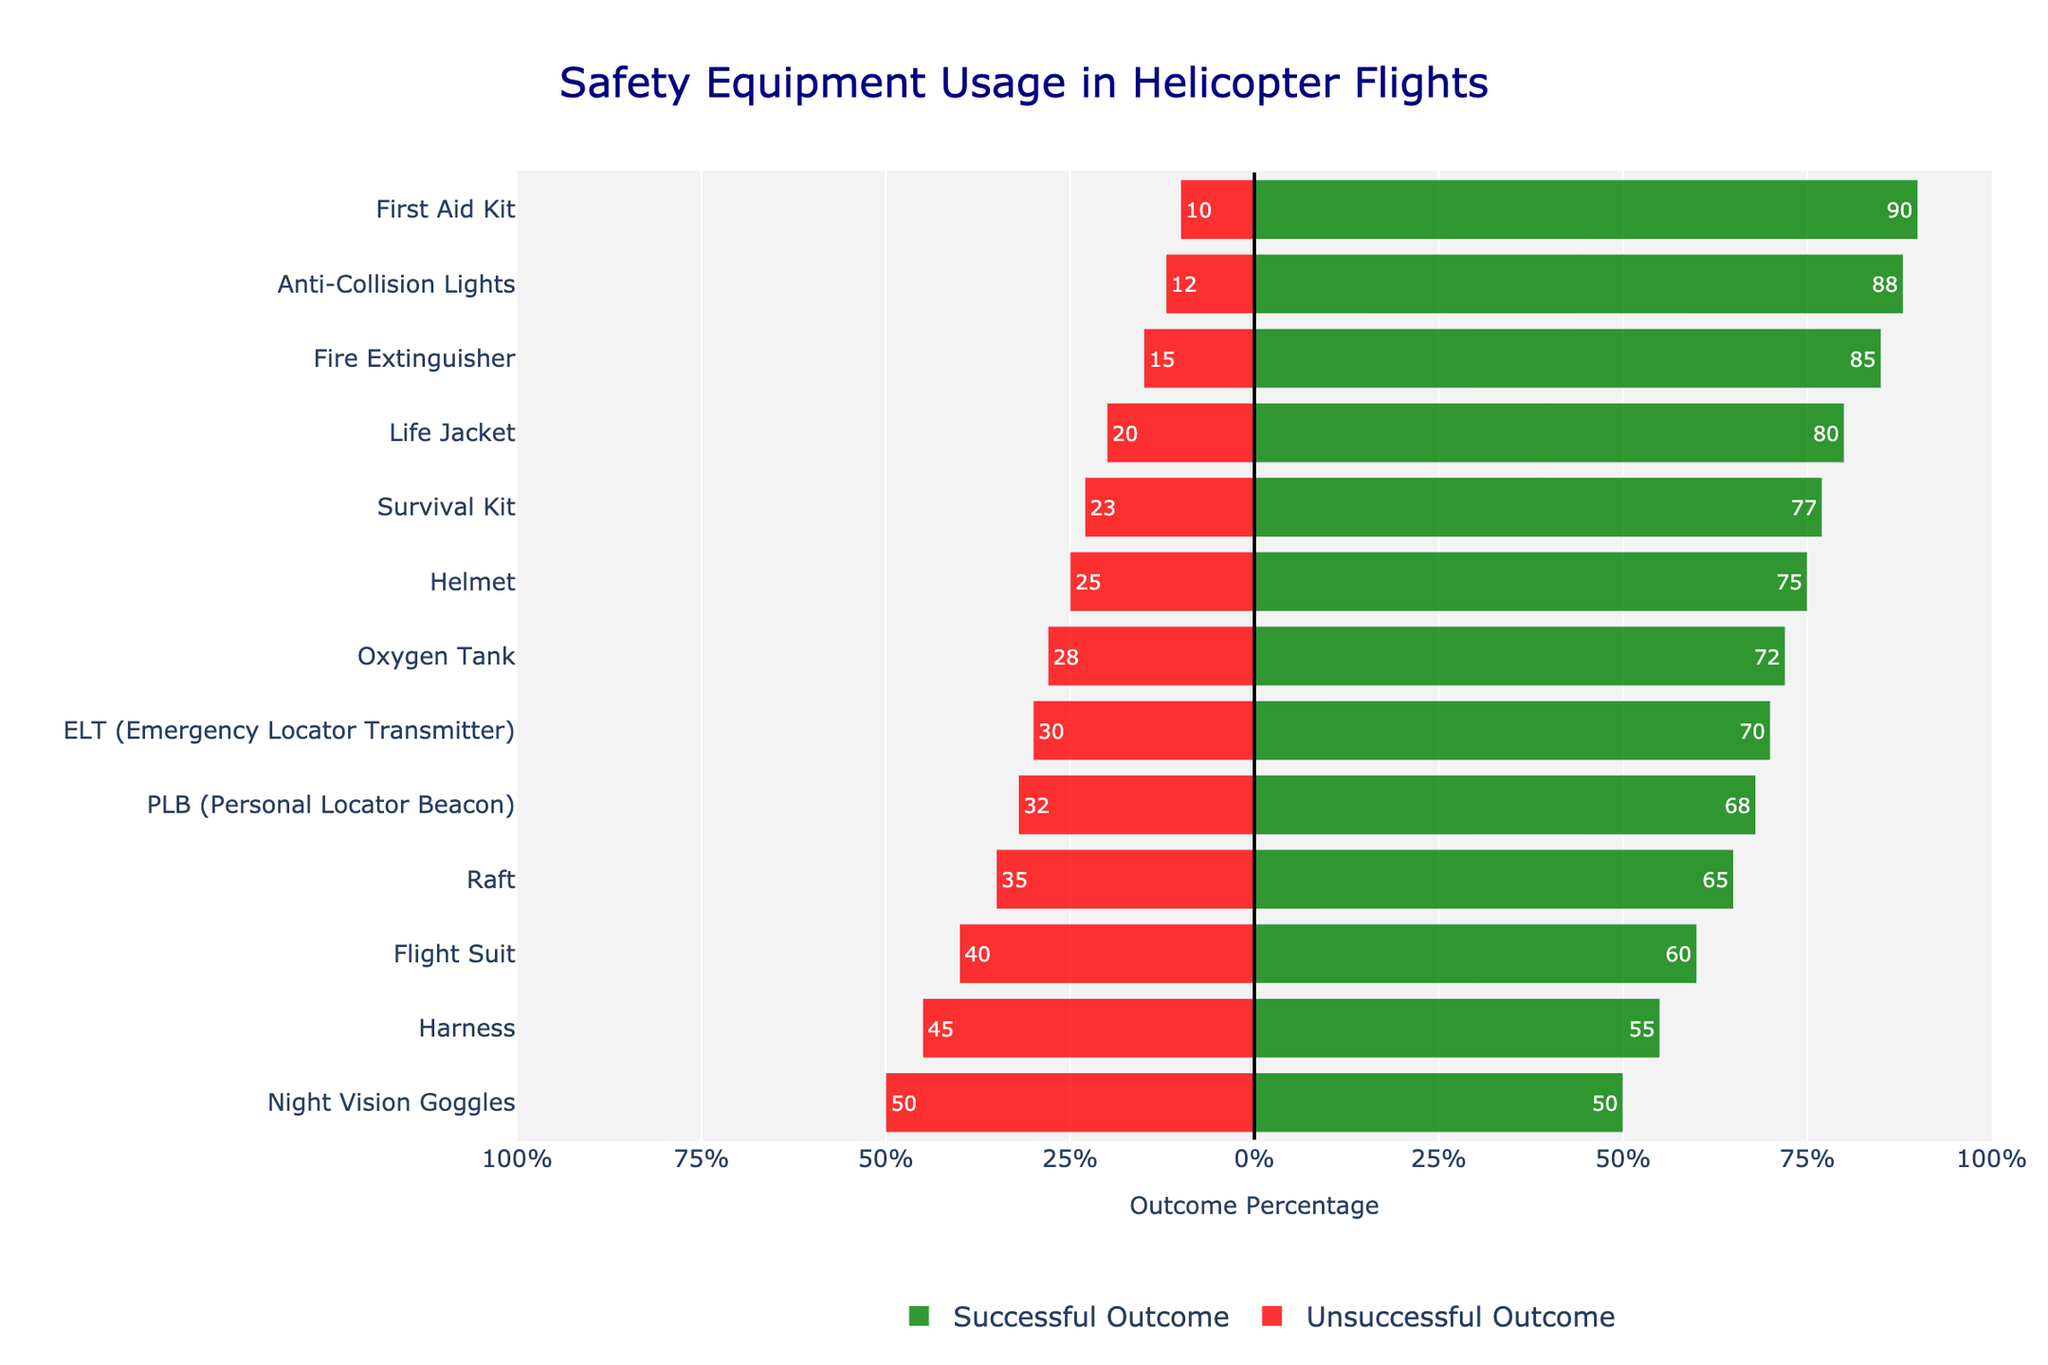What safety equipment has the highest percentage of successful outcomes? The bar indicating the highest percentage of successful outcomes should be the longest green bar in the figure. Looking at these lengths, the First Aid Kit has the highest percentage with its green bar extending to 90%.
Answer: First Aid Kit Which safety equipment has an equal percentage of successful and unsuccessful outcomes? The balance means that the bars for both successful and unsuccessful outcomes will be of equal length. From the chart, the Night Vision Goggles have equal bars at 50%.
Answer: Night Vision Goggles How many safety equipment types have more than 70% successful outcomes? Count the number of green bars that extend beyond the 70% mark. First Aid Kit, Fire Extinguisher, Anti-Collision Lights, Life Jacket, and Survival Kit are above 70%, making a total of 5.
Answer: 5 Which safety equipment has the lowest percentage of successful outcomes and what is that percentage? The lowest percentage is indicated by the shortest green bar. The Night Vision Goggles have the shortest green bar, which is at 50%.
Answer: Night Vision Goggles, 50% Compare the use of the harness and the harness's outcomes. Which one has a higher percentage of successful outcomes? Compare the lengths of the green bars for both the Flight Suit and Harness. The green bar for the Flight Suit is longer at 60%, while the Harness is at 55%. Therefore, the Flight Suit has a higher successful outcome percentage.
Answer: Flight Suit What is the combined percentage of unsuccessful outcomes for PLB and ELT equipment? Add the unsuccessful outcomes of both PLB (32%) and ELT (30%) to get the combined percentage. This sum is 32 + 30 = 62%.
Answer: 62% Is the percentage of successful outcomes for the Life Jacket closer to the percentage for the Raft or the Oxygen Tank? Compare the green bar lengths. The Life Jacket is at 80%, the Raft at 65%, and the Oxygen Tank at 72%. The difference between Life Jacket and Raft is 80 - 65 = 15%, while the difference between Life Jacket and Oxygen Tank is 80 - 72 = 8%. The Oxygen Tank is closer.
Answer: Oxygen Tank Which two safety equipment types have the closest percentages of successful outcomes? Identify green bars with lengths close to each other. PLB (68%) and Oxygen Tank (72%) have only a 4% difference, making them the closest.
Answer: PLB and Oxygen Tank What is the difference in percentage between successful outcomes for the Fire Extinguisher and the Raft? Subtract the successful outcomes percentage of the Raft from the Fire Extinguisher. This difference is 85% - 65% = 20%.
Answer: 20% Which safety equipment shows a higher percentage of unsuccessful outcomes than successful outcomes, and what is the percentage of unsuccessful outcomes for that equipment? Identify bars where the red bar is longer than the green bar. Only the Night Vision Goggles have a red bar longer than or equal to the green bar, with both at 50%. The unsuccessful outcome is 50%.
Answer: Night Vision Goggles, 50% 